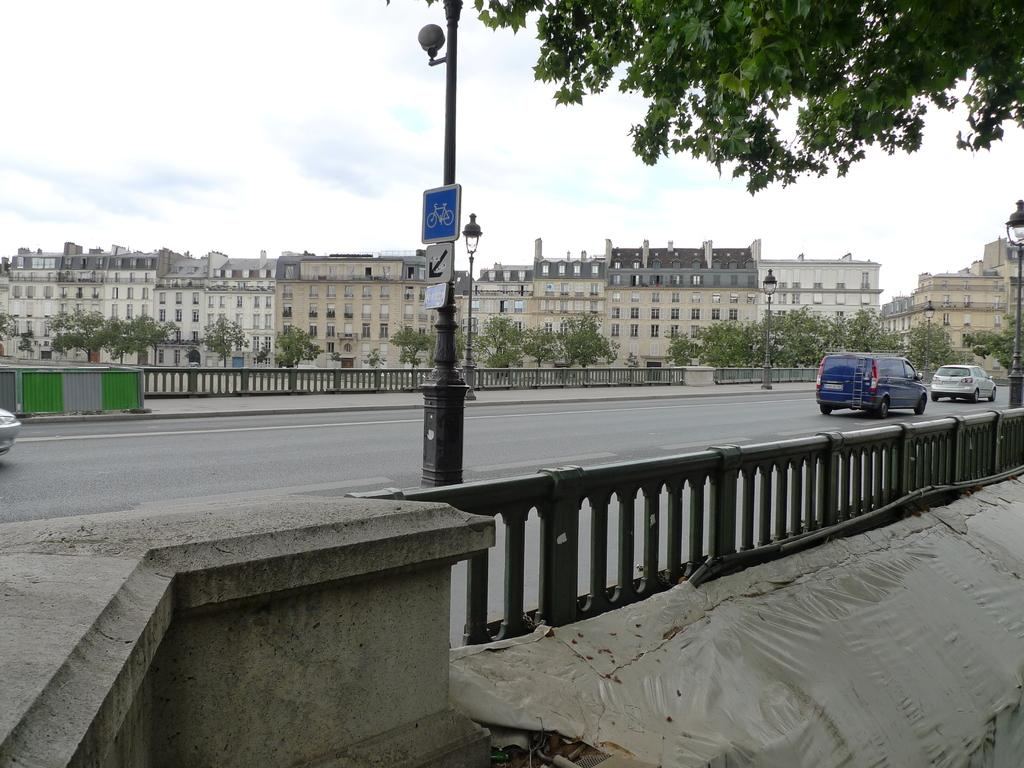What is happening on the road in the image? There are vehicles on the road in the image. What else can be seen in the image besides the vehicles? Boards and electric poles with lights are visible in the image. What can be seen in the background of the image? There are buildings, trees, and the sky visible in the background of the image. What type of print can be seen on the walls of the hall in the image? There is no hall or print present in the image; it features vehicles on the road, boards, electric poles with lights, and a background with buildings, trees, and the sky. 